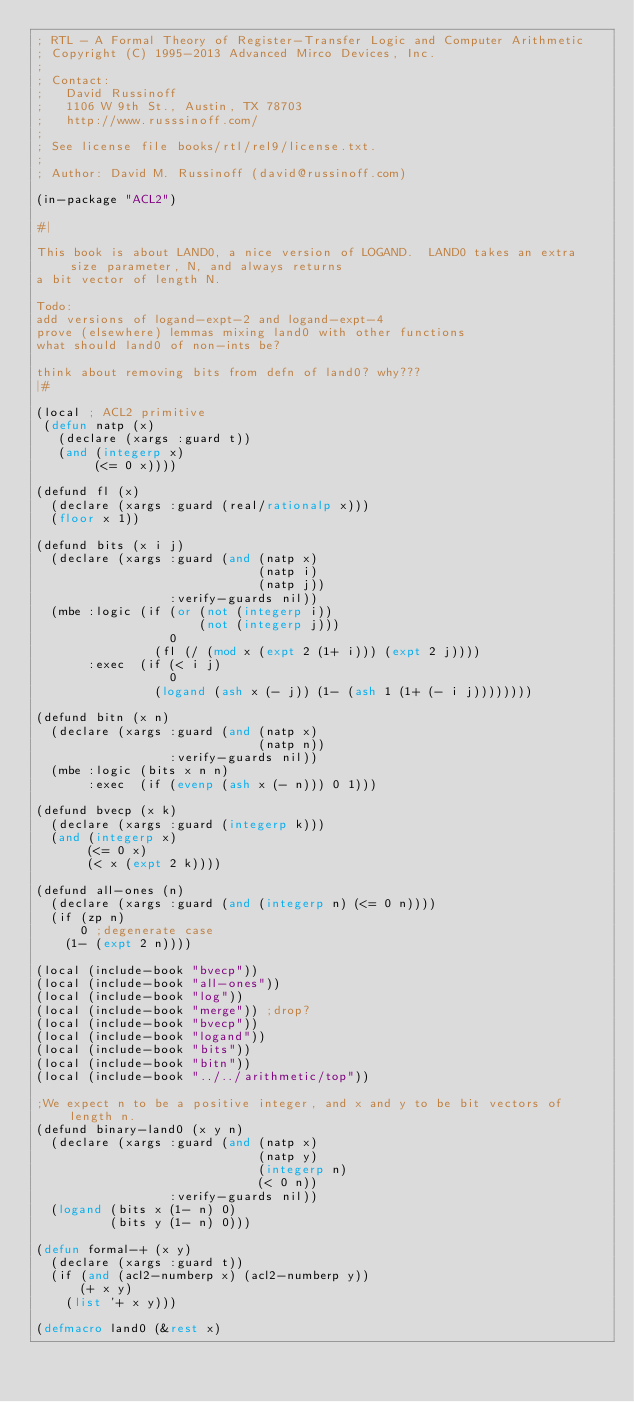Convert code to text. <code><loc_0><loc_0><loc_500><loc_500><_Lisp_>; RTL - A Formal Theory of Register-Transfer Logic and Computer Arithmetic
; Copyright (C) 1995-2013 Advanced Mirco Devices, Inc.
;
; Contact:
;   David Russinoff
;   1106 W 9th St., Austin, TX 78703
;   http://www.russsinoff.com/
;
; See license file books/rtl/rel9/license.txt.
;
; Author: David M. Russinoff (david@russinoff.com)

(in-package "ACL2")

#|

This book is about LAND0, a nice version of LOGAND.  LAND0 takes an extra size parameter, N, and always returns
a bit vector of length N.

Todo:
add versions of logand-expt-2 and logand-expt-4
prove (elsewhere) lemmas mixing land0 with other functions
what should land0 of non-ints be?

think about removing bits from defn of land0? why???
|#

(local ; ACL2 primitive
 (defun natp (x)
   (declare (xargs :guard t))
   (and (integerp x)
        (<= 0 x))))

(defund fl (x)
  (declare (xargs :guard (real/rationalp x)))
  (floor x 1))

(defund bits (x i j)
  (declare (xargs :guard (and (natp x)
                              (natp i)
                              (natp j))
                  :verify-guards nil))
  (mbe :logic (if (or (not (integerp i))
                      (not (integerp j)))
                  0
                (fl (/ (mod x (expt 2 (1+ i))) (expt 2 j))))
       :exec  (if (< i j)
                  0
                (logand (ash x (- j)) (1- (ash 1 (1+ (- i j))))))))

(defund bitn (x n)
  (declare (xargs :guard (and (natp x)
                              (natp n))
                  :verify-guards nil))
  (mbe :logic (bits x n n)
       :exec  (if (evenp (ash x (- n))) 0 1)))

(defund bvecp (x k)
  (declare (xargs :guard (integerp k)))
  (and (integerp x)
       (<= 0 x)
       (< x (expt 2 k))))

(defund all-ones (n)
  (declare (xargs :guard (and (integerp n) (<= 0 n))))
  (if (zp n)
      0 ;degenerate case
    (1- (expt 2 n))))

(local (include-book "bvecp"))
(local (include-book "all-ones"))
(local (include-book "log"))
(local (include-book "merge")) ;drop?
(local (include-book "bvecp"))
(local (include-book "logand"))
(local (include-book "bits"))
(local (include-book "bitn"))
(local (include-book "../../arithmetic/top"))

;We expect n to be a positive integer, and x and y to be bit vectors of length n.
(defund binary-land0 (x y n)
  (declare (xargs :guard (and (natp x)
                              (natp y)
                              (integerp n)
                              (< 0 n))
                  :verify-guards nil))
  (logand (bits x (1- n) 0)
          (bits y (1- n) 0)))

(defun formal-+ (x y)
  (declare (xargs :guard t))
  (if (and (acl2-numberp x) (acl2-numberp y))
      (+ x y)
    (list '+ x y)))

(defmacro land0 (&rest x)</code> 